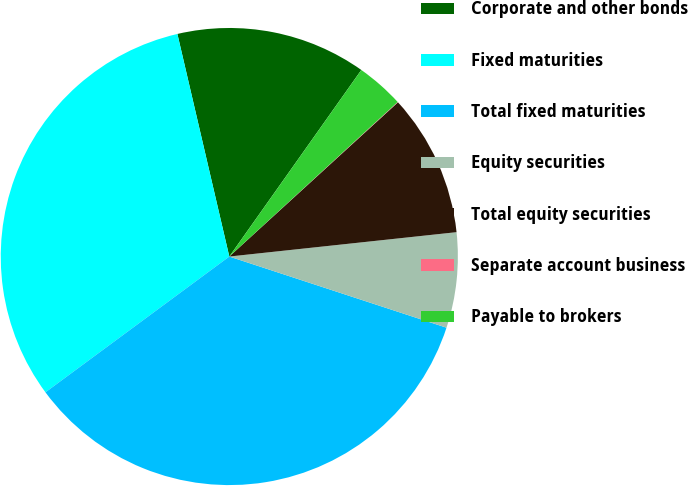Convert chart. <chart><loc_0><loc_0><loc_500><loc_500><pie_chart><fcel>Corporate and other bonds<fcel>Fixed maturities<fcel>Total fixed maturities<fcel>Equity securities<fcel>Total equity securities<fcel>Separate account business<fcel>Payable to brokers<nl><fcel>13.45%<fcel>31.48%<fcel>34.84%<fcel>6.74%<fcel>10.09%<fcel>0.03%<fcel>3.38%<nl></chart> 